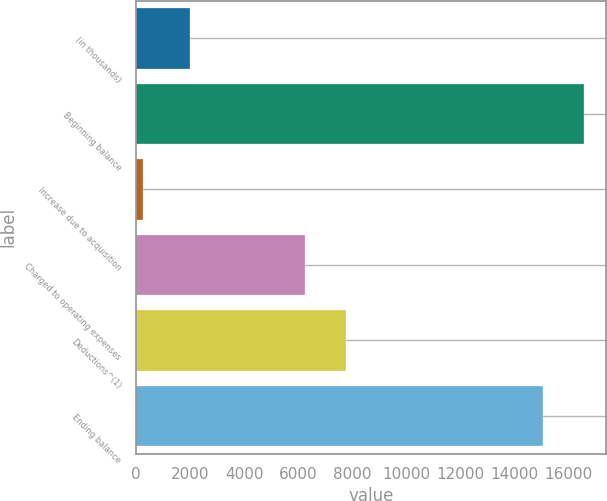<chart> <loc_0><loc_0><loc_500><loc_500><bar_chart><fcel>(in thousands)<fcel>Beginning balance<fcel>Increase due to acquisition<fcel>Charged to operating expenses<fcel>Deductions^(1)<fcel>Ending balance<nl><fcel>2011<fcel>16576.4<fcel>269<fcel>6271<fcel>7767.4<fcel>15080<nl></chart> 